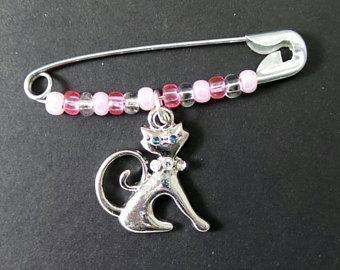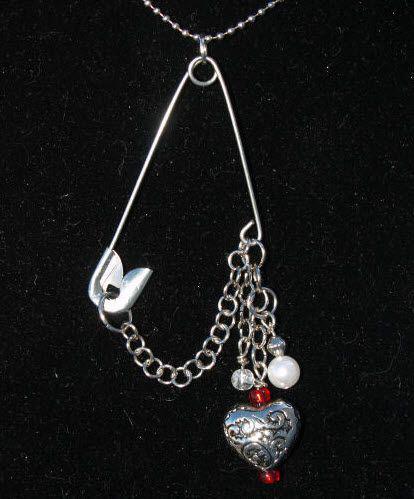The first image is the image on the left, the second image is the image on the right. Considering the images on both sides, is "1 safety pin is in front of a white dish." valid? Answer yes or no. No. 